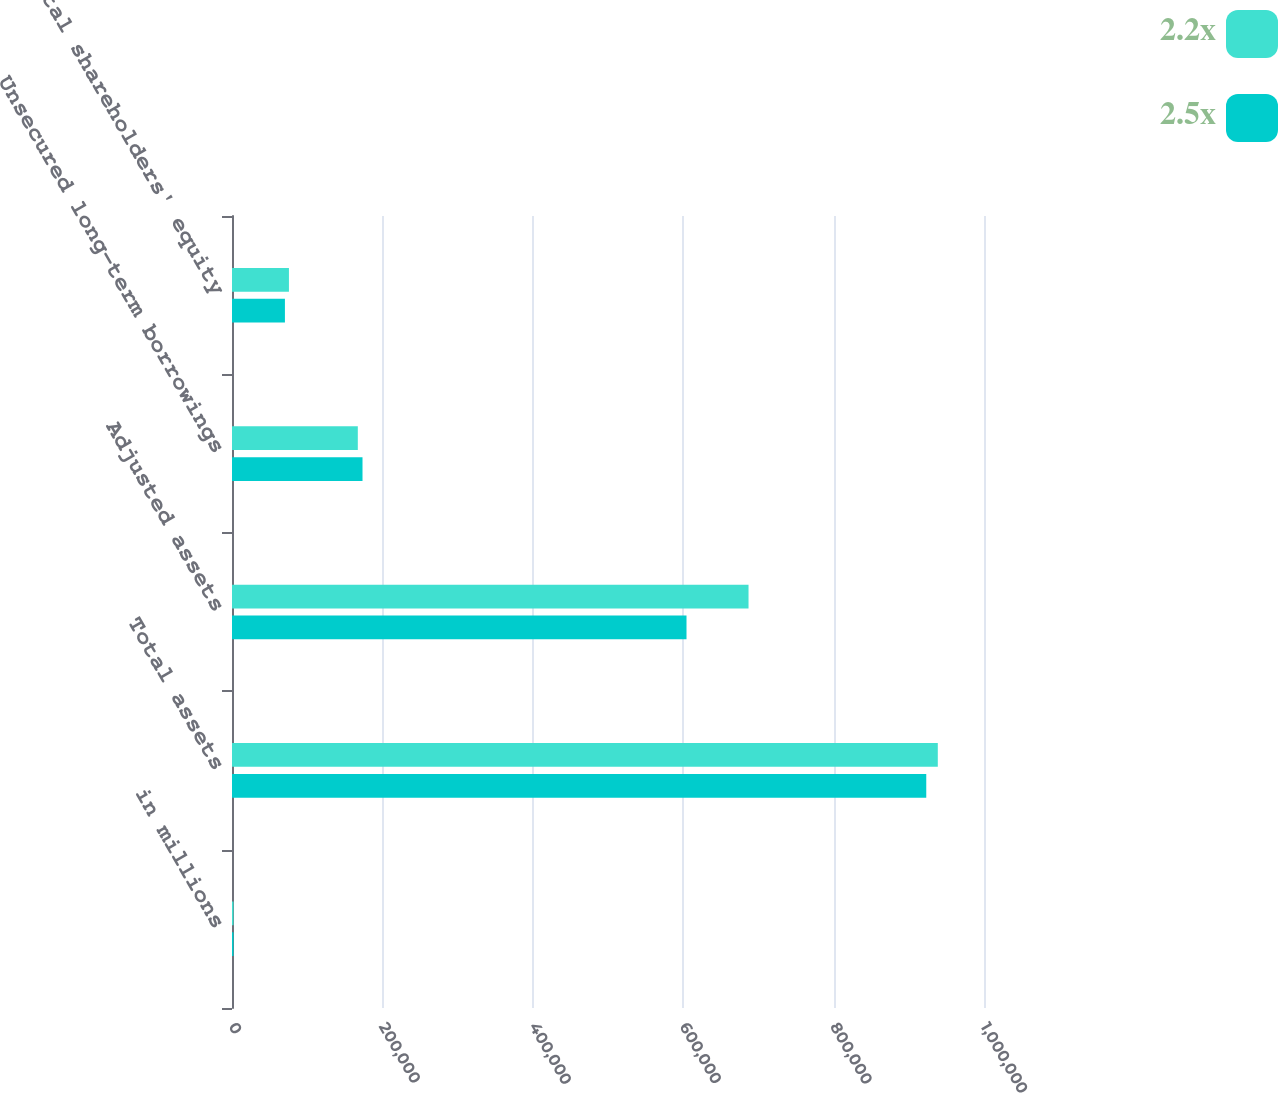<chart> <loc_0><loc_0><loc_500><loc_500><stacked_bar_chart><ecel><fcel>in millions<fcel>Total assets<fcel>Adjusted assets<fcel>Unsecured long-term borrowings<fcel>Total shareholders' equity<nl><fcel>2.2x<fcel>2012<fcel>938555<fcel>686874<fcel>167305<fcel>75716<nl><fcel>2.5x<fcel>2011<fcel>923225<fcel>604391<fcel>173545<fcel>70379<nl></chart> 